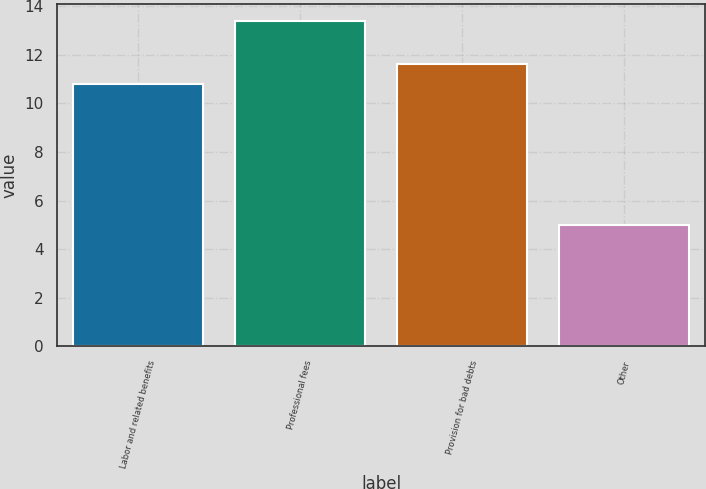<chart> <loc_0><loc_0><loc_500><loc_500><bar_chart><fcel>Labor and related benefits<fcel>Professional fees<fcel>Provision for bad debts<fcel>Other<nl><fcel>10.8<fcel>13.4<fcel>11.64<fcel>5<nl></chart> 